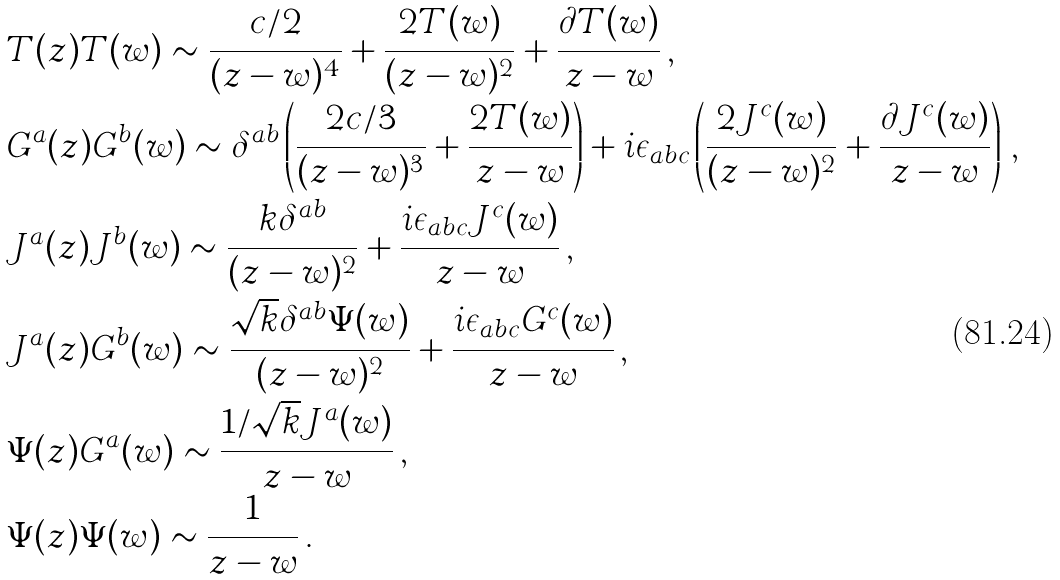Convert formula to latex. <formula><loc_0><loc_0><loc_500><loc_500>& T ( z ) T ( w ) \sim \frac { c / 2 } { ( z - w ) ^ { 4 } } + \frac { 2 T ( w ) } { ( z - w ) ^ { 2 } } + \frac { \partial T ( w ) } { z - w } \, , \\ & G ^ { a } ( z ) G ^ { b } ( w ) \sim \delta ^ { a b } \left ( \frac { 2 c / 3 } { ( z - w ) ^ { 3 } } + \frac { 2 T ( w ) } { z - w } \right ) + i \epsilon _ { a b c } \left ( \frac { 2 J ^ { c } ( w ) } { ( z - w ) ^ { 2 } } + \frac { \partial J ^ { c } ( w ) } { z - w } \right ) \, , \\ & J ^ { a } ( z ) J ^ { b } ( w ) \sim \frac { k \delta ^ { a b } } { ( z - w ) ^ { 2 } } + \frac { i \epsilon _ { a b c } J ^ { c } ( w ) } { z - w } \, , \\ & J ^ { a } ( z ) G ^ { b } ( w ) \sim \frac { \sqrt { k } \delta ^ { a b } \Psi ( w ) } { ( z - w ) ^ { 2 } } + \frac { i \epsilon _ { a b c } G ^ { c } ( w ) } { z - w } \, , \\ & \Psi ( z ) G ^ { a } ( w ) \sim \frac { 1 / \sqrt { k } J ^ { a } ( w ) } { z - w } \, , \\ & \Psi ( z ) \Psi ( w ) \sim \frac { 1 } { z - w } \, .</formula> 